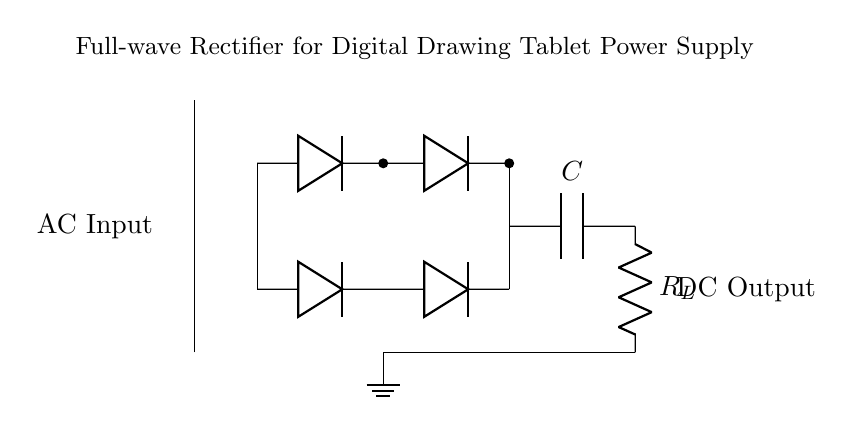What type of rectifier is shown in the circuit? The circuit diagram depicts a full-wave rectifier, which means it converts both halves of the AC waveform into DC. The presence of two pairs of diodes indicates it's a full-wave configuration.
Answer: full-wave What components are used in the circuit? The circuit includes a transformer, diodes, a capacitor, and a resistor. The transformer converts the AC voltage, while the diodes rectify the AC to DC. The capacitor smooths the output, and the resistor represents the load.
Answer: transformer, diodes, capacitor, resistor What is the function of the capacitor in this circuit? The capacitor in this circuit is used for smoothing the output voltage. It charges during the peak of the rectified voltage and discharges to provide a steady DC voltage, filtering out voltage fluctuations.
Answer: smoothing How many diodes are used in the bridge rectifier? The bridge rectifier comprises four diodes arranged in a configuration that allows current to flow through either half of the AC signal. Counting the diodes shown in the diagram gives a total of four.
Answer: four What is the output type of this rectifier circuit? The output of this full-wave rectifier circuit is direct current (DC). The diodes rectify the incoming alternating current, ensuring that the output only flows in one direction, thus creating DC.
Answer: direct current What is the role of the resistor labeled as R_L? The resistor, labeled R_L, acts as the load for the rectifier circuit. It consumes the electrical power provided by the rectified output, and its presence allows for the measurement of current flow and voltage across it.
Answer: load What is the voltage at the DC output? The DC output voltage is determined by the peak voltage of the AC input minus the forward voltage drop across the diodes. Generally, the value can be estimated based on design but is not explicitly given in the circuit diagram.
Answer: depends on AC input 